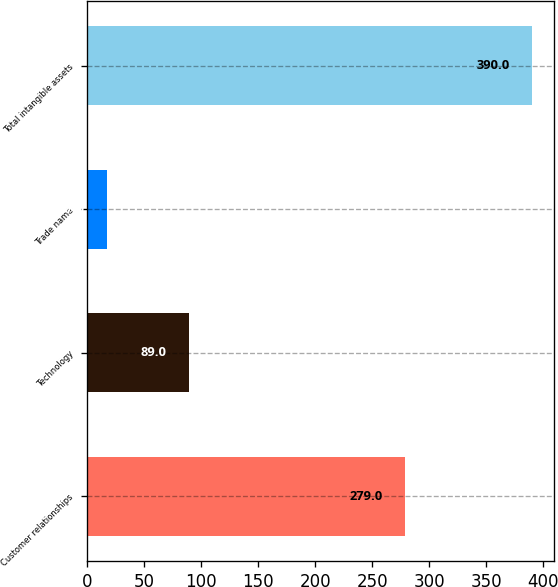Convert chart. <chart><loc_0><loc_0><loc_500><loc_500><bar_chart><fcel>Customer relationships<fcel>Technology<fcel>Trade name<fcel>Total intangible assets<nl><fcel>279<fcel>89<fcel>17<fcel>390<nl></chart> 